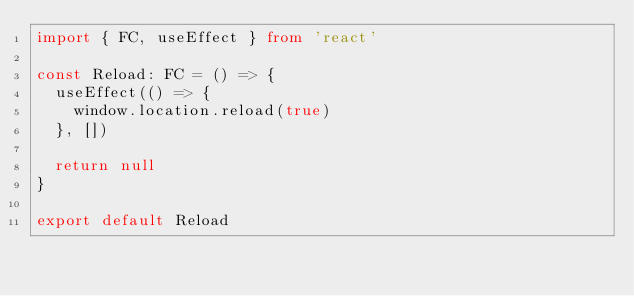Convert code to text. <code><loc_0><loc_0><loc_500><loc_500><_TypeScript_>import { FC, useEffect } from 'react'

const Reload: FC = () => {
  useEffect(() => {
    window.location.reload(true)
  }, [])

  return null
}

export default Reload
</code> 